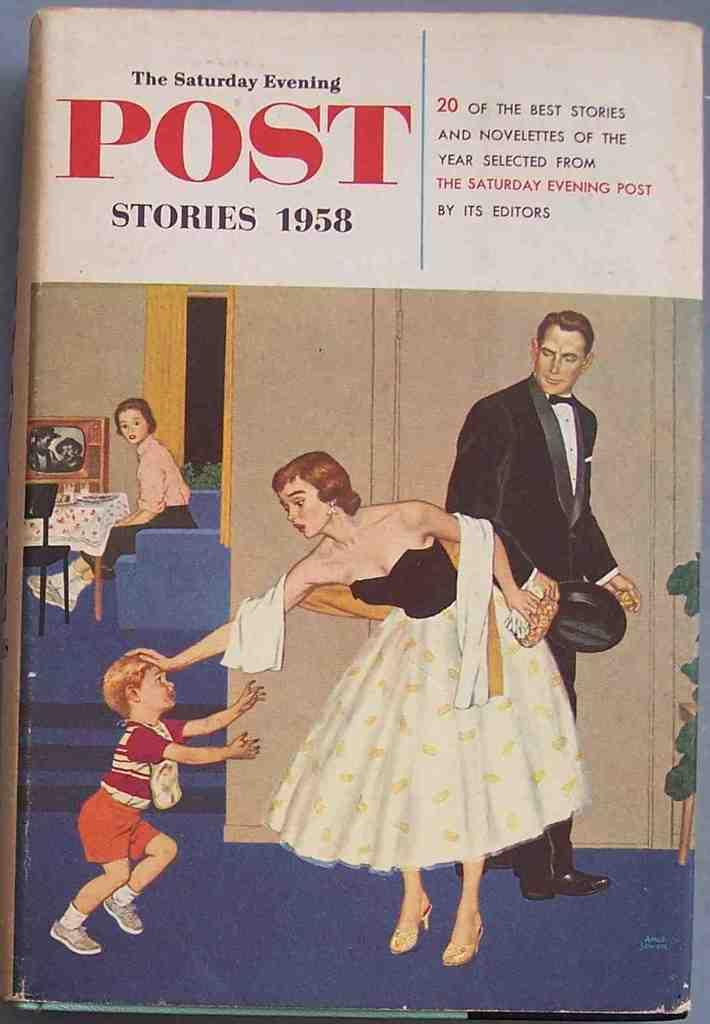What is present in the image that contains images and text? There is a poster in the image that contains images and text. Where is the lunchroom located in the image? There is no lunchroom present in the image; it only contains a poster with images and text. On which side of the poster is the text located? The provided facts do not specify the location of the text on the poster, so we cannot definitively answer this question. 